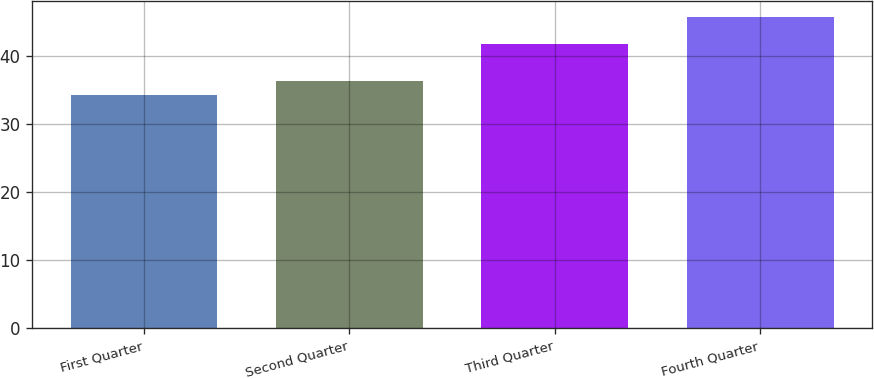Convert chart to OTSL. <chart><loc_0><loc_0><loc_500><loc_500><bar_chart><fcel>First Quarter<fcel>Second Quarter<fcel>Third Quarter<fcel>Fourth Quarter<nl><fcel>34.19<fcel>36.24<fcel>41.66<fcel>45.68<nl></chart> 